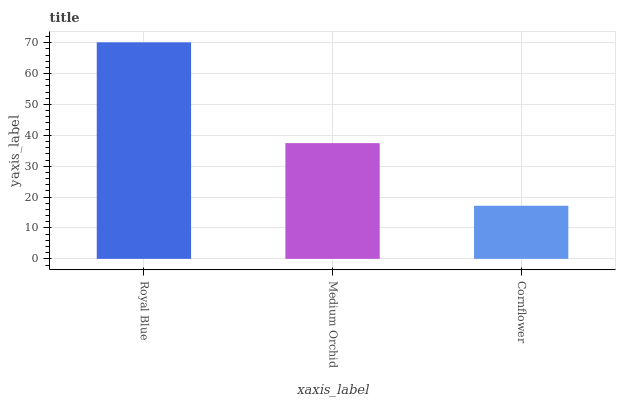Is Cornflower the minimum?
Answer yes or no. Yes. Is Royal Blue the maximum?
Answer yes or no. Yes. Is Medium Orchid the minimum?
Answer yes or no. No. Is Medium Orchid the maximum?
Answer yes or no. No. Is Royal Blue greater than Medium Orchid?
Answer yes or no. Yes. Is Medium Orchid less than Royal Blue?
Answer yes or no. Yes. Is Medium Orchid greater than Royal Blue?
Answer yes or no. No. Is Royal Blue less than Medium Orchid?
Answer yes or no. No. Is Medium Orchid the high median?
Answer yes or no. Yes. Is Medium Orchid the low median?
Answer yes or no. Yes. Is Royal Blue the high median?
Answer yes or no. No. Is Cornflower the low median?
Answer yes or no. No. 